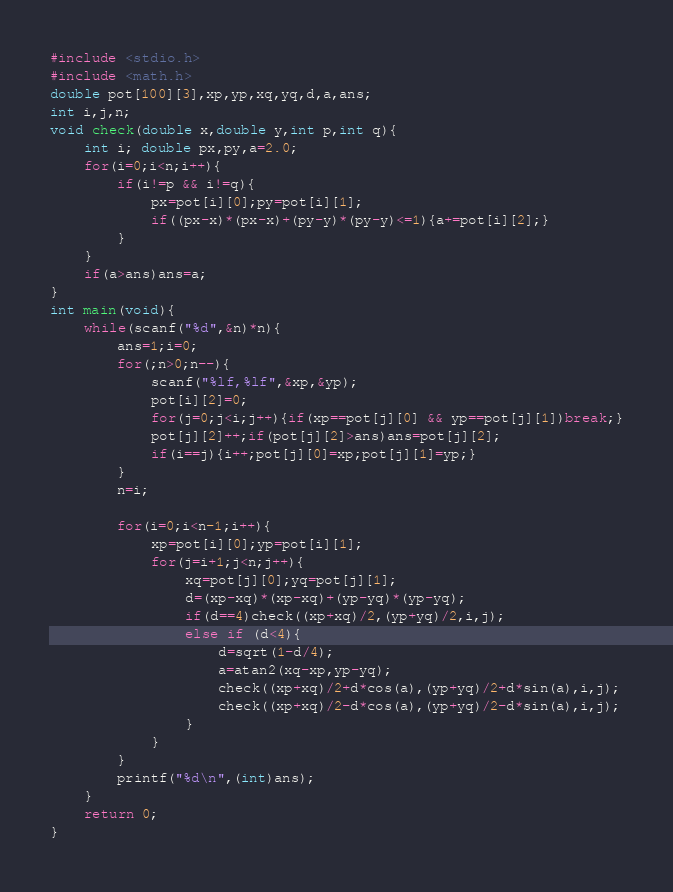<code> <loc_0><loc_0><loc_500><loc_500><_C_>#include <stdio.h>
#include <math.h>
double pot[100][3],xp,yp,xq,yq,d,a,ans;
int i,j,n;
void check(double x,double y,int p,int q){
	int i; double px,py,a=2.0;
	for(i=0;i<n;i++){
		if(i!=p && i!=q){
			px=pot[i][0];py=pot[i][1];
			if((px-x)*(px-x)+(py-y)*(py-y)<=1){a+=pot[i][2];}
		}
	}
	if(a>ans)ans=a;
}
int main(void){
	while(scanf("%d",&n)*n){
		ans=1;i=0;
		for(;n>0;n--){
			scanf("%lf,%lf",&xp,&yp);
			pot[i][2]=0;
			for(j=0;j<i;j++){if(xp==pot[j][0] && yp==pot[j][1])break;}
			pot[j][2]++;if(pot[j][2]>ans)ans=pot[j][2];
			if(i==j){i++;pot[j][0]=xp;pot[j][1]=yp;}
		}
		n=i;

		for(i=0;i<n-1;i++){
			xp=pot[i][0];yp=pot[i][1];
			for(j=i+1;j<n;j++){
				xq=pot[j][0];yq=pot[j][1];
				d=(xp-xq)*(xp-xq)+(yp-yq)*(yp-yq);
				if(d==4)check((xp+xq)/2,(yp+yq)/2,i,j);
				else if (d<4){
					d=sqrt(1-d/4);
					a=atan2(xq-xp,yp-yq);
					check((xp+xq)/2+d*cos(a),(yp+yq)/2+d*sin(a),i,j);
					check((xp+xq)/2-d*cos(a),(yp+yq)/2-d*sin(a),i,j);
				}
			}
		}
		printf("%d\n",(int)ans);
	}
	return 0;
}</code> 